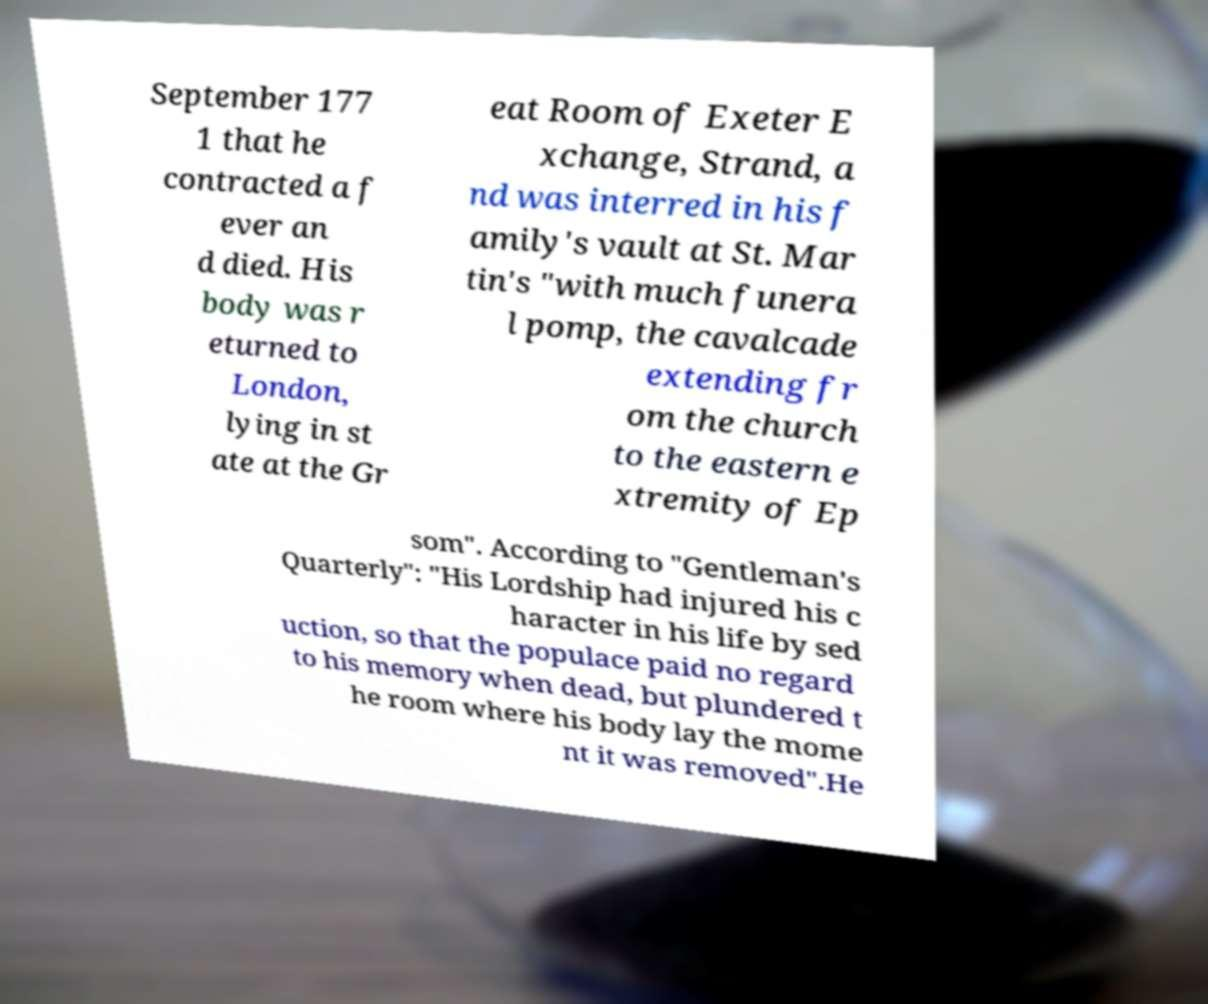There's text embedded in this image that I need extracted. Can you transcribe it verbatim? September 177 1 that he contracted a f ever an d died. His body was r eturned to London, lying in st ate at the Gr eat Room of Exeter E xchange, Strand, a nd was interred in his f amily's vault at St. Mar tin's "with much funera l pomp, the cavalcade extending fr om the church to the eastern e xtremity of Ep som". According to "Gentleman's Quarterly": "His Lordship had injured his c haracter in his life by sed uction, so that the populace paid no regard to his memory when dead, but plundered t he room where his body lay the mome nt it was removed".He 